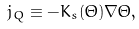Convert formula to latex. <formula><loc_0><loc_0><loc_500><loc_500>j _ { Q } \equiv - K _ { s } ( \Theta ) \nabla \Theta ,</formula> 